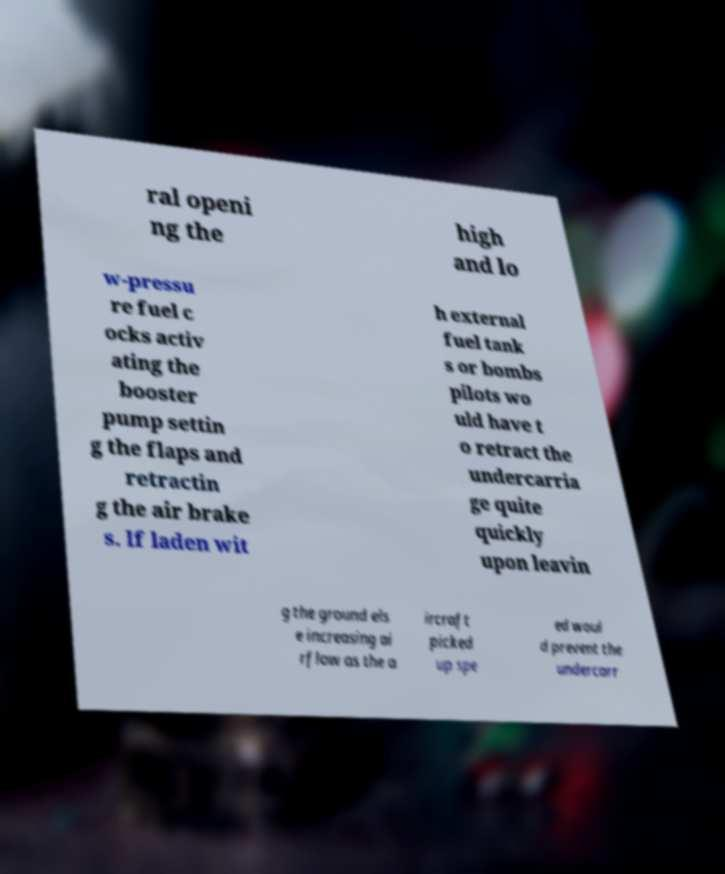Please identify and transcribe the text found in this image. ral openi ng the high and lo w-pressu re fuel c ocks activ ating the booster pump settin g the flaps and retractin g the air brake s. If laden wit h external fuel tank s or bombs pilots wo uld have t o retract the undercarria ge quite quickly upon leavin g the ground els e increasing ai rflow as the a ircraft picked up spe ed woul d prevent the undercarr 